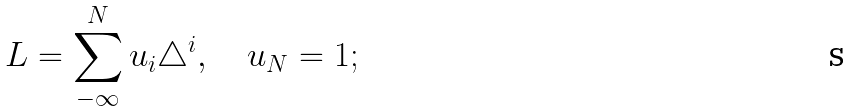Convert formula to latex. <formula><loc_0><loc_0><loc_500><loc_500>L = \sum ^ { N } _ { - \infty } u _ { i } \triangle ^ { i } , \quad u _ { N } = 1 ;</formula> 